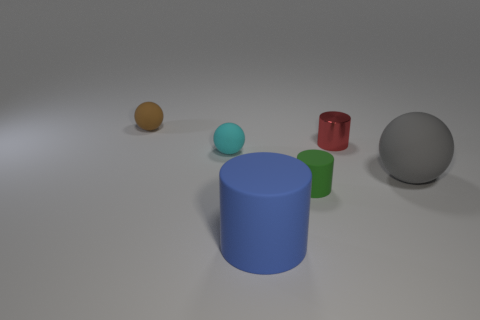Add 3 red objects. How many objects exist? 9 Add 6 brown rubber spheres. How many brown rubber spheres are left? 7 Add 6 small rubber things. How many small rubber things exist? 9 Subtract 0 purple cubes. How many objects are left? 6 Subtract all yellow rubber balls. Subtract all tiny red objects. How many objects are left? 5 